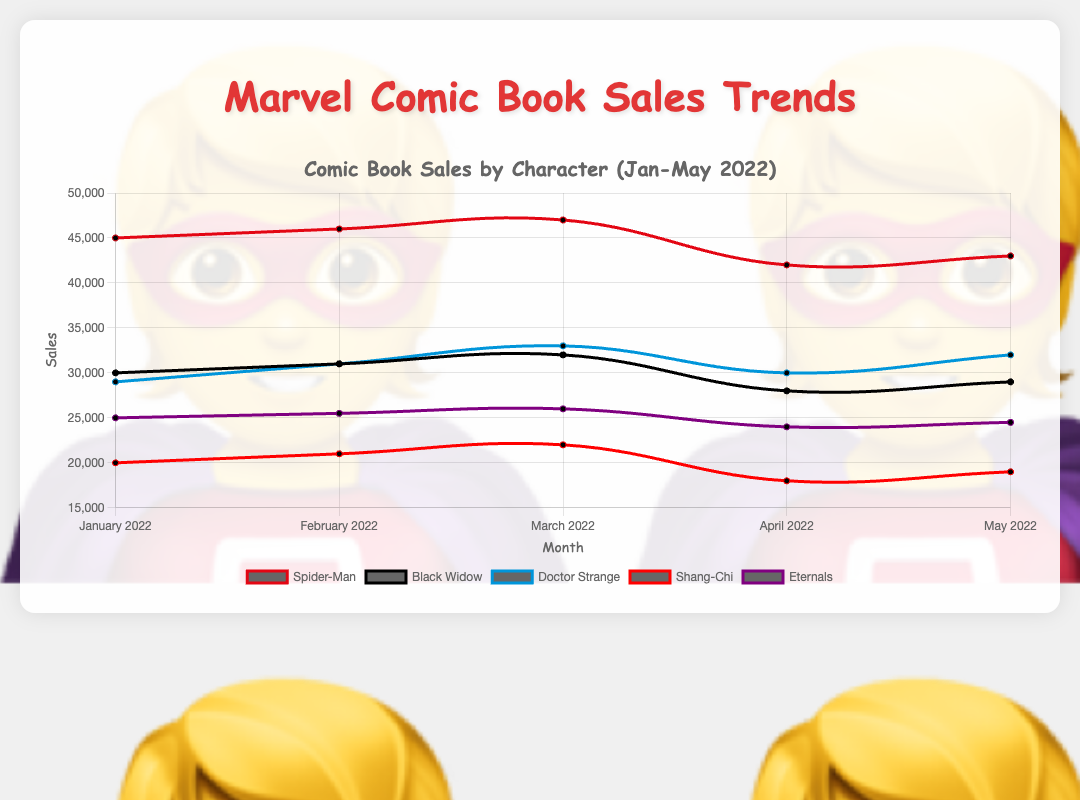Which character had the highest sales in January 2022? By observing the line chart, look for the highest point in January 2022 across all characters. Spider-Man has the highest sales with 45,000.
Answer: Spider-Man How did Black Widow's sales change from February to April 2022? In February 2022, Black Widow's sales were 31,000, and in April 2022, they dropped to 28,000. The change is calculated as 31,000 - 28,000 = 3,000.
Answer: Decreased by 3,000 Which two characters experienced a drop in sales from March to April 2022? Look at the sales values for each character in March and April 2022. Spider-Man and Shang-Chi both had a decrease in sales from March to April. Spider-Man's sales dropped from 47,000 to 42,000, and Shang-Chi's sales dropped from 22,000 to 18,000.
Answer: Spider-Man and Shang-Chi What is the average sales value for Doctor Strange across the five months? Sum Doctor Strange's sales values from January to May 2022 (29,000 + 31,000 + 33,000 + 30,000 + 32,000) and divide by 5. The average sales value is (29,000 + 31,000 + 33,000 + 30,000 + 32,000) / 5 = 31,000.
Answer: 31,000 Compare the sales trend of Spider-Man and Eternals from February to May 2022. What differences can you observe? Eternals' sales rose steadily from February to March (25,500 to 26,000) before declining in April and May (24,000 to 24,500). Spider-Man's sales also rose steadily in earlier months, peaking in March (47,000), but dropped significantly in April (42,000) before slightly recovering in May.
Answer: Spider-Man had a more pronounced drop in sales What is the total combined sales of Shang-Chi and Black Widow in March 2022? Sum the sales for Shang-Chi and Black Widow in March 2022. Shang-Chi had 22,000 sales, and Black Widow had 32,000 sales. Combined, it is 22,000 + 32,000 = 54,000.
Answer: 54,000 Which character had the most consistent sales trend from January to May 2022? Evaluate the fluctuation in sales for each character over the given months. Eternals show the most consistent trend with small increases and decreases, without sharp fluctuations, compared to other characters like Spider-Man or Shang-Chi.
Answer: Eternals How do the sales between Doctor Strange and Shang-Chi in May 2022 differ? Look at the sales figures for May 2022. Doctor Strange had 32,000 sales and Shang-Chi had 19,000 sales. The difference can be calculated as 32,000 - 19,000 = 13,000.
Answer: Doctor Strange had 13,000 more sales What was the percentage drop in sales for Spider-Man from March to April 2022? Calculate the percentage drop from March to April for Spider-Man. March sales were 47,000 and April sales were 42,000. Percentage drop = ((47,000 - 42,000) / 47,000) * 100 ≈ 10.64%.
Answer: Approximately 10.64% Which month recorded the lowest sales for Shang-Chi? Compare Shang-Chi's sales across the months. The lowest sales for Shang-Chi were in April 2022, with 18,000 sales.
Answer: April 2022 